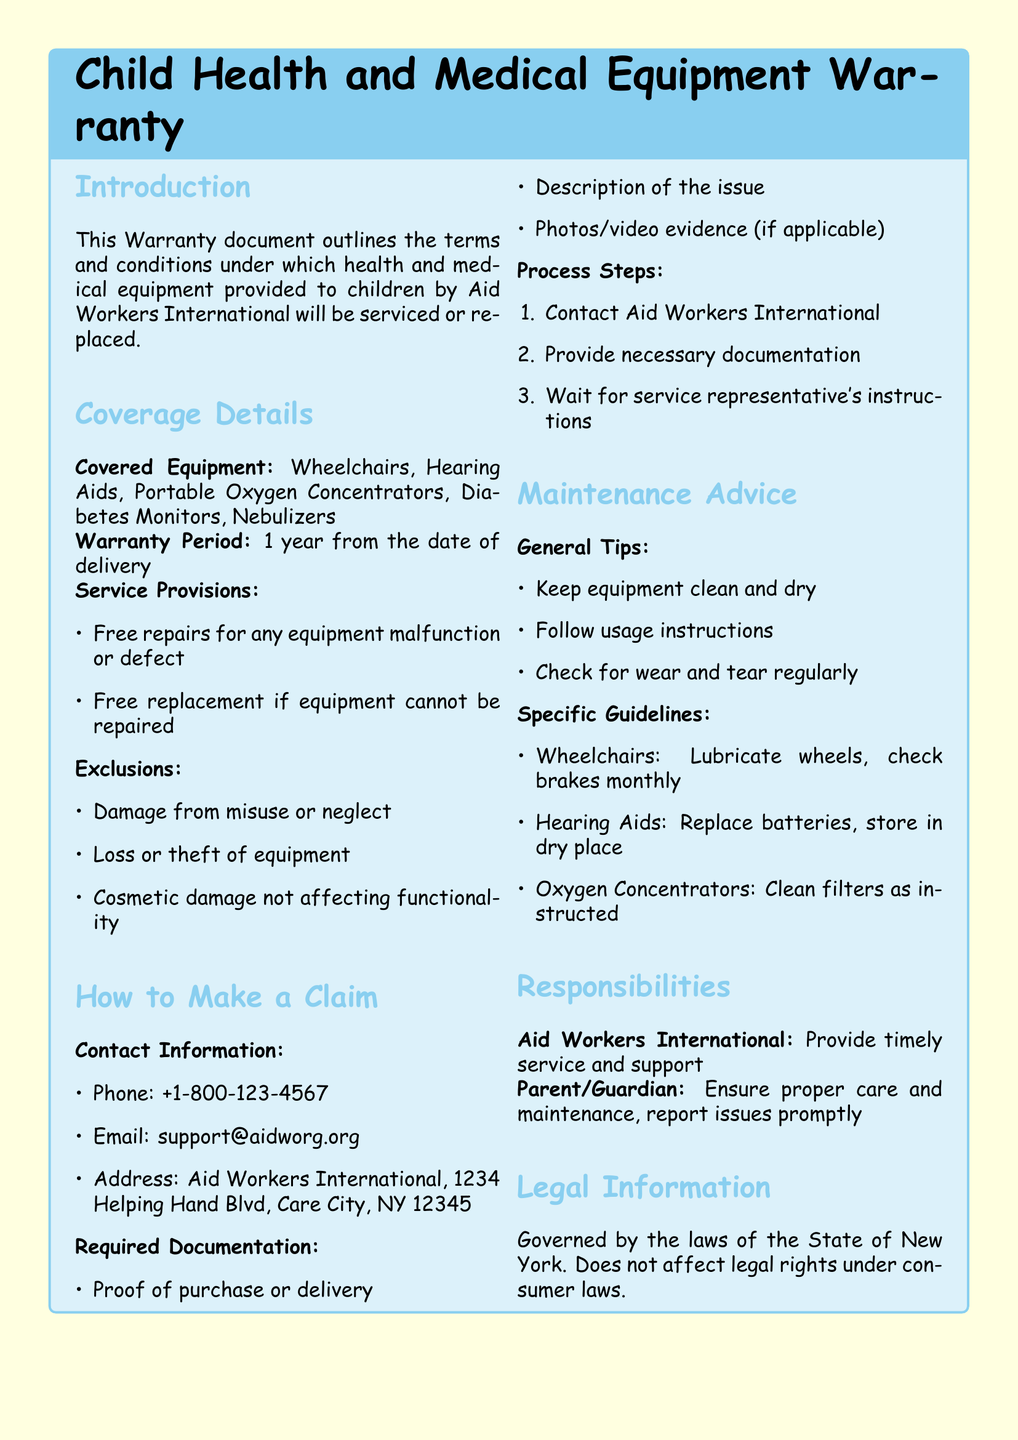What is the warranty period? The warranty period is stated as 1 year from the date of delivery.
Answer: 1 year Which equipment is covered? The document specifies the equipment that is covered under the warranty, including wheelchairs and others.
Answer: Wheelchairs, Hearing Aids, Portable Oxygen Concentrators, Diabetes Monitors, Nebulizers What should I do if my equipment cannot be repaired? The document mentions that free replacement will occur if equipment cannot be repaired.
Answer: Free replacement What are the exclusions? The document lists specific situations where coverage does not apply, essential for understanding warranty limitations.
Answer: Damage from misuse or neglect, Loss or theft of equipment, Cosmetic damage not affecting functionality What is needed to make a claim? Information on required documentation to support a claim is outlined in the document.
Answer: Proof of purchase or delivery, Description of the issue, Photos/video evidence Who is responsible for proper care and maintenance? The document assigns specific responsibilities, indicating who should ensure care of the equipment.
Answer: Parent/Guardian What contact method is provided for claims? The document lists ways to get in touch for making a warranty claim, which is vital for the process.
Answer: Phone, Email, Address What are the general maintenance tips? Identifying maintenance suggestions helps ensure equipment longevity and functionality as noted in the document.
Answer: Keep equipment clean and dry, Follow usage instructions, Check for wear and tear regularly 